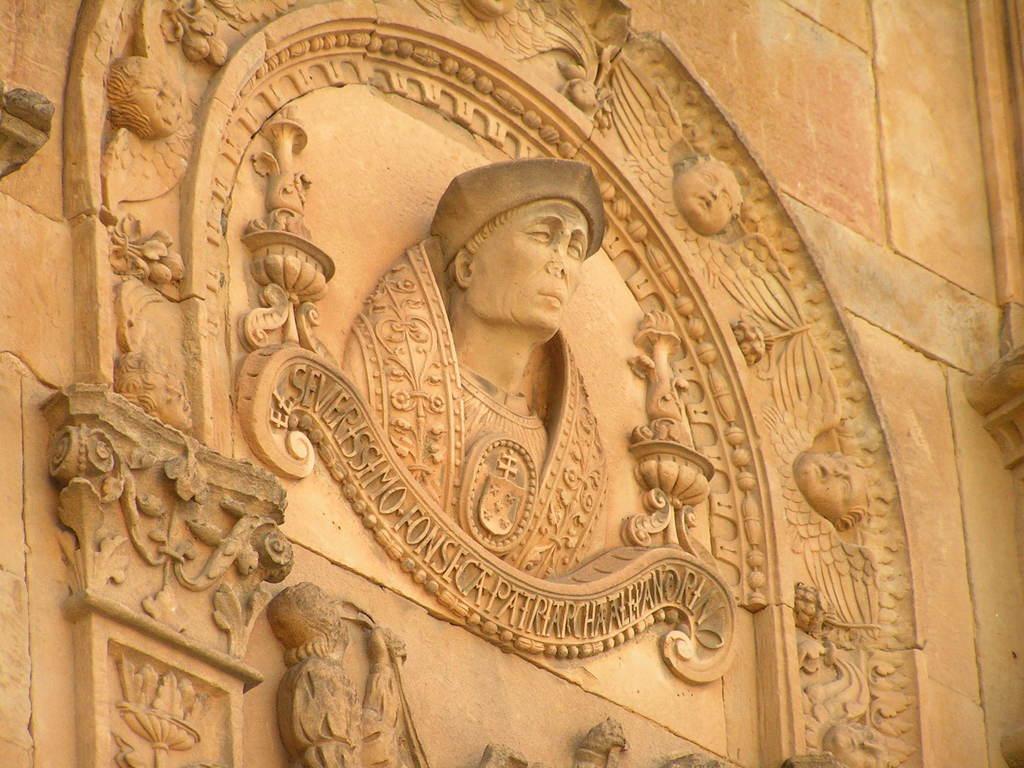Can you describe this image briefly? In the picture we can see a historical building wall with some sculptures on it of a person and something written on it. 